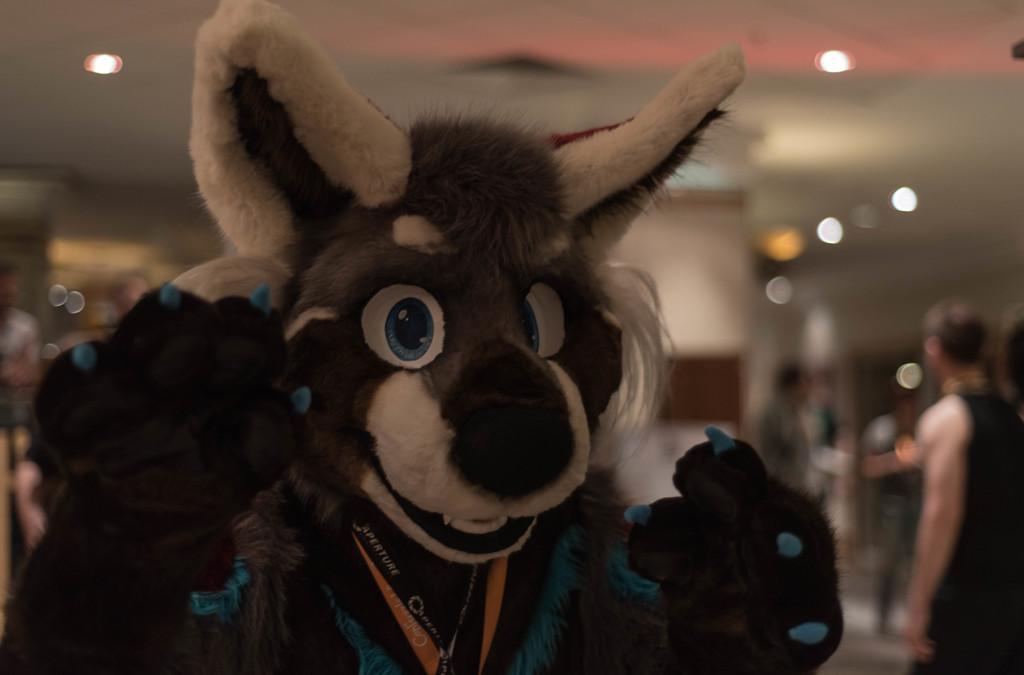Describe this image in one or two sentences. Here we can see a mascot. In the background the image is blur but we can see lights on the roof top and few people standing on the floor. 